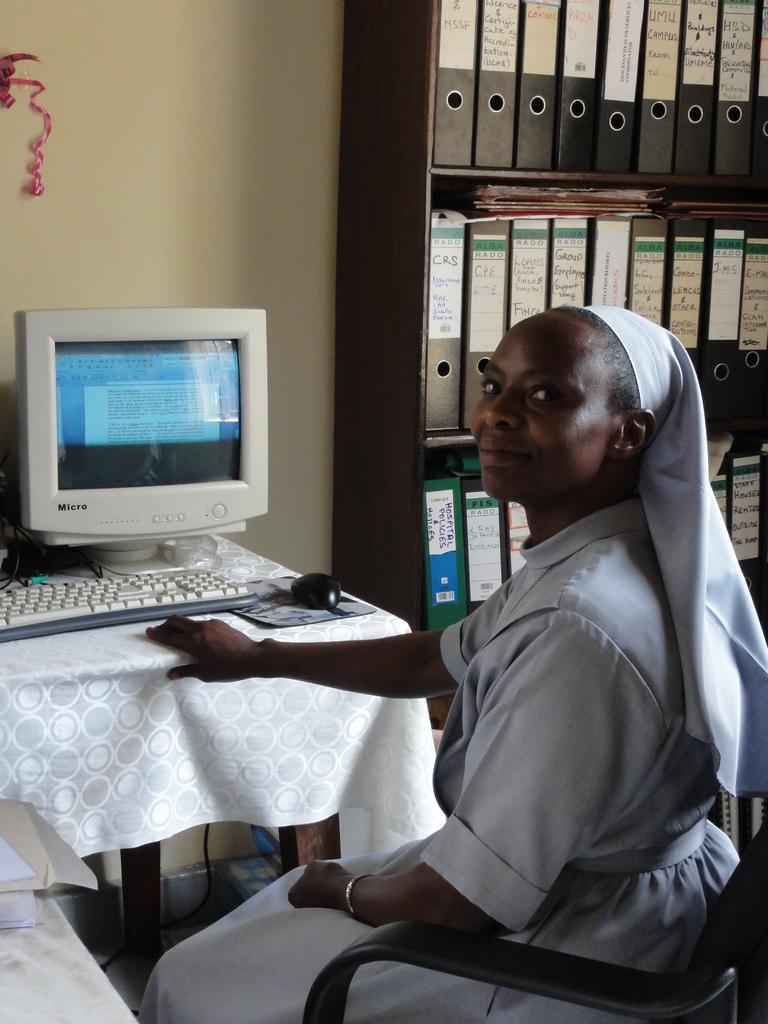What can be seen on the left side of the image? There is a computer system on the left side of the image. What is the woman in the image doing? The woman is sitting in a chair on the right side of the image. What is located behind the woman in the image? There is a shelf of files behind the woman. What type of voyage is the woman planning in the image? There is no indication of a voyage in the image; the woman is simply sitting in a chair. Can you describe the geese that are present in the image? There are no geese present in the image. 